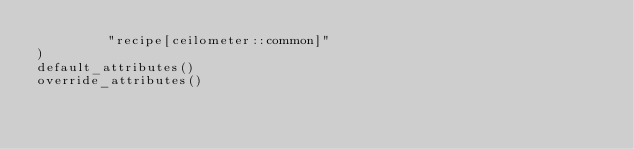Convert code to text. <code><loc_0><loc_0><loc_500><loc_500><_Ruby_>         "recipe[ceilometer::common]"         
)
default_attributes()
override_attributes()

</code> 